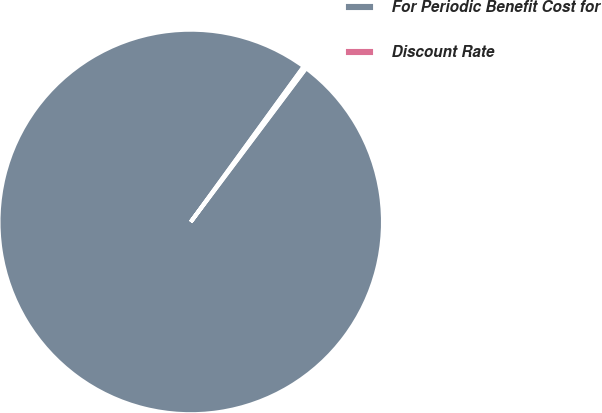Convert chart to OTSL. <chart><loc_0><loc_0><loc_500><loc_500><pie_chart><fcel>For Periodic Benefit Cost for<fcel>Discount Rate<nl><fcel>99.75%<fcel>0.25%<nl></chart> 